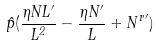Convert formula to latex. <formula><loc_0><loc_0><loc_500><loc_500>\hat { p } ( \frac { \eta N L ^ { \prime } } { L ^ { 2 } } - \frac { \eta N ^ { \prime } } { L } + { N ^ { r } } ^ { \prime } )</formula> 